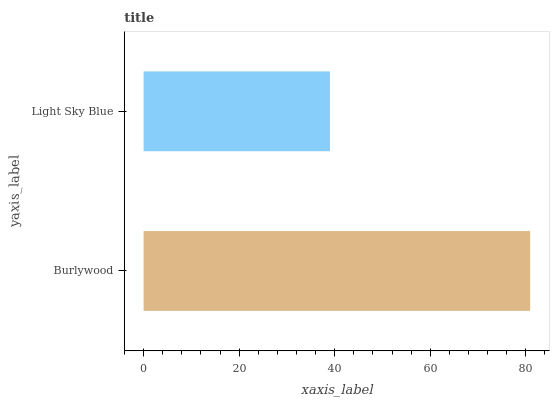Is Light Sky Blue the minimum?
Answer yes or no. Yes. Is Burlywood the maximum?
Answer yes or no. Yes. Is Light Sky Blue the maximum?
Answer yes or no. No. Is Burlywood greater than Light Sky Blue?
Answer yes or no. Yes. Is Light Sky Blue less than Burlywood?
Answer yes or no. Yes. Is Light Sky Blue greater than Burlywood?
Answer yes or no. No. Is Burlywood less than Light Sky Blue?
Answer yes or no. No. Is Burlywood the high median?
Answer yes or no. Yes. Is Light Sky Blue the low median?
Answer yes or no. Yes. Is Light Sky Blue the high median?
Answer yes or no. No. Is Burlywood the low median?
Answer yes or no. No. 